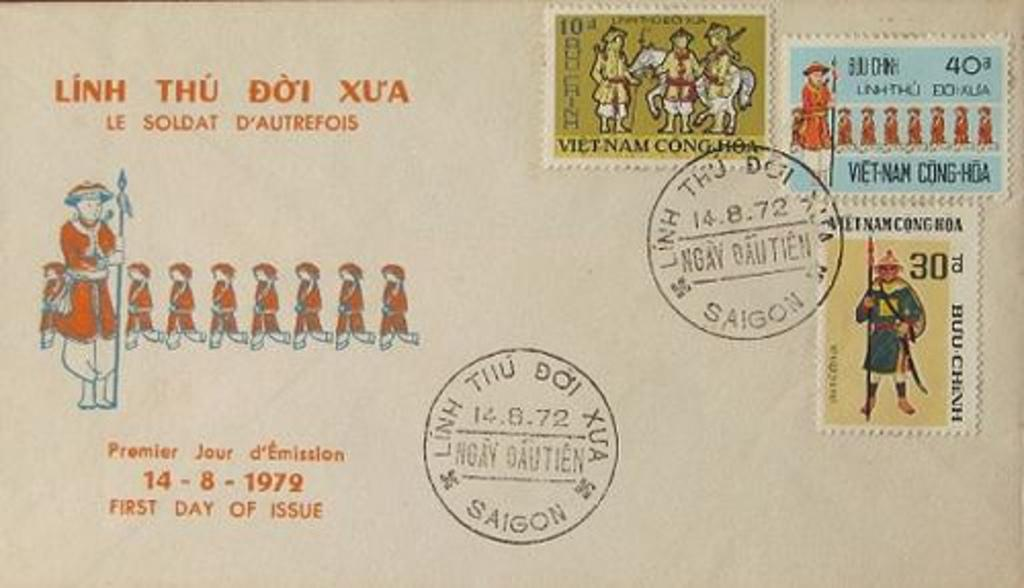<image>
Describe the image concisely. The postage stamps on this envelop indicate that this was mailed from Vietnam. 